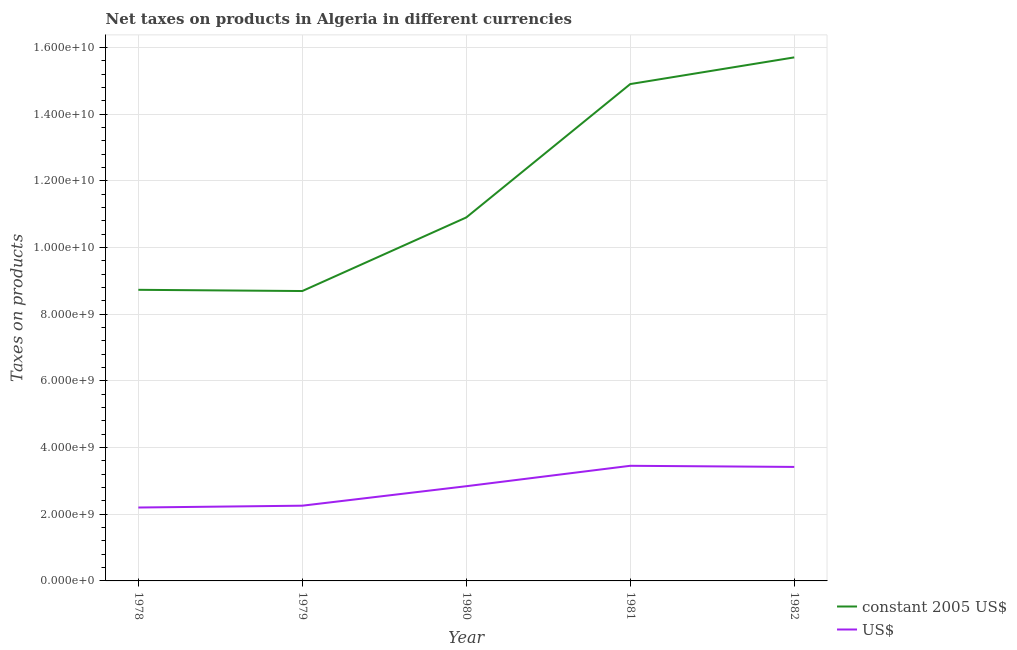How many different coloured lines are there?
Offer a terse response. 2. Does the line corresponding to net taxes in us$ intersect with the line corresponding to net taxes in constant 2005 us$?
Give a very brief answer. No. Is the number of lines equal to the number of legend labels?
Ensure brevity in your answer.  Yes. What is the net taxes in us$ in 1982?
Keep it short and to the point. 3.42e+09. Across all years, what is the maximum net taxes in constant 2005 us$?
Ensure brevity in your answer.  1.57e+1. Across all years, what is the minimum net taxes in constant 2005 us$?
Give a very brief answer. 8.69e+09. In which year was the net taxes in constant 2005 us$ minimum?
Make the answer very short. 1979. What is the total net taxes in constant 2005 us$ in the graph?
Give a very brief answer. 5.89e+1. What is the difference between the net taxes in us$ in 1979 and that in 1982?
Offer a very short reply. -1.16e+09. What is the difference between the net taxes in us$ in 1980 and the net taxes in constant 2005 us$ in 1982?
Make the answer very short. -1.29e+1. What is the average net taxes in us$ per year?
Keep it short and to the point. 2.83e+09. In the year 1982, what is the difference between the net taxes in us$ and net taxes in constant 2005 us$?
Provide a succinct answer. -1.23e+1. What is the ratio of the net taxes in us$ in 1981 to that in 1982?
Your response must be concise. 1.01. Is the net taxes in us$ in 1978 less than that in 1980?
Give a very brief answer. Yes. What is the difference between the highest and the second highest net taxes in constant 2005 us$?
Your answer should be compact. 8.00e+08. What is the difference between the highest and the lowest net taxes in us$?
Give a very brief answer. 1.25e+09. Is the sum of the net taxes in constant 2005 us$ in 1978 and 1982 greater than the maximum net taxes in us$ across all years?
Provide a succinct answer. Yes. Does the net taxes in constant 2005 us$ monotonically increase over the years?
Your response must be concise. No. Is the net taxes in us$ strictly less than the net taxes in constant 2005 us$ over the years?
Your answer should be compact. Yes. How many years are there in the graph?
Ensure brevity in your answer.  5. Does the graph contain any zero values?
Provide a short and direct response. No. Does the graph contain grids?
Your response must be concise. Yes. Where does the legend appear in the graph?
Offer a very short reply. Bottom right. What is the title of the graph?
Keep it short and to the point. Net taxes on products in Algeria in different currencies. Does "From World Bank" appear as one of the legend labels in the graph?
Provide a short and direct response. No. What is the label or title of the Y-axis?
Give a very brief answer. Taxes on products. What is the Taxes on products of constant 2005 US$ in 1978?
Ensure brevity in your answer.  8.73e+09. What is the Taxes on products of US$ in 1978?
Ensure brevity in your answer.  2.20e+09. What is the Taxes on products of constant 2005 US$ in 1979?
Offer a very short reply. 8.69e+09. What is the Taxes on products of US$ in 1979?
Keep it short and to the point. 2.26e+09. What is the Taxes on products in constant 2005 US$ in 1980?
Your answer should be very brief. 1.09e+1. What is the Taxes on products in US$ in 1980?
Give a very brief answer. 2.84e+09. What is the Taxes on products in constant 2005 US$ in 1981?
Provide a succinct answer. 1.49e+1. What is the Taxes on products of US$ in 1981?
Give a very brief answer. 3.45e+09. What is the Taxes on products of constant 2005 US$ in 1982?
Provide a short and direct response. 1.57e+1. What is the Taxes on products of US$ in 1982?
Give a very brief answer. 3.42e+09. Across all years, what is the maximum Taxes on products of constant 2005 US$?
Give a very brief answer. 1.57e+1. Across all years, what is the maximum Taxes on products in US$?
Your response must be concise. 3.45e+09. Across all years, what is the minimum Taxes on products of constant 2005 US$?
Give a very brief answer. 8.69e+09. Across all years, what is the minimum Taxes on products of US$?
Provide a succinct answer. 2.20e+09. What is the total Taxes on products of constant 2005 US$ in the graph?
Ensure brevity in your answer.  5.89e+1. What is the total Taxes on products of US$ in the graph?
Offer a very short reply. 1.42e+1. What is the difference between the Taxes on products of constant 2005 US$ in 1978 and that in 1979?
Your answer should be compact. 3.64e+07. What is the difference between the Taxes on products of US$ in 1978 and that in 1979?
Provide a short and direct response. -5.49e+07. What is the difference between the Taxes on products of constant 2005 US$ in 1978 and that in 1980?
Offer a terse response. -2.17e+09. What is the difference between the Taxes on products of US$ in 1978 and that in 1980?
Provide a succinct answer. -6.39e+08. What is the difference between the Taxes on products of constant 2005 US$ in 1978 and that in 1981?
Your answer should be compact. -6.17e+09. What is the difference between the Taxes on products in US$ in 1978 and that in 1981?
Give a very brief answer. -1.25e+09. What is the difference between the Taxes on products in constant 2005 US$ in 1978 and that in 1982?
Provide a succinct answer. -6.97e+09. What is the difference between the Taxes on products of US$ in 1978 and that in 1982?
Offer a terse response. -1.22e+09. What is the difference between the Taxes on products of constant 2005 US$ in 1979 and that in 1980?
Provide a short and direct response. -2.21e+09. What is the difference between the Taxes on products in US$ in 1979 and that in 1980?
Offer a terse response. -5.84e+08. What is the difference between the Taxes on products in constant 2005 US$ in 1979 and that in 1981?
Provide a succinct answer. -6.21e+09. What is the difference between the Taxes on products of US$ in 1979 and that in 1981?
Keep it short and to the point. -1.20e+09. What is the difference between the Taxes on products of constant 2005 US$ in 1979 and that in 1982?
Your answer should be very brief. -7.01e+09. What is the difference between the Taxes on products of US$ in 1979 and that in 1982?
Ensure brevity in your answer.  -1.16e+09. What is the difference between the Taxes on products of constant 2005 US$ in 1980 and that in 1981?
Provide a short and direct response. -4.00e+09. What is the difference between the Taxes on products in US$ in 1980 and that in 1981?
Make the answer very short. -6.12e+08. What is the difference between the Taxes on products in constant 2005 US$ in 1980 and that in 1982?
Ensure brevity in your answer.  -4.80e+09. What is the difference between the Taxes on products in US$ in 1980 and that in 1982?
Provide a short and direct response. -5.78e+08. What is the difference between the Taxes on products in constant 2005 US$ in 1981 and that in 1982?
Give a very brief answer. -8.00e+08. What is the difference between the Taxes on products of US$ in 1981 and that in 1982?
Give a very brief answer. 3.36e+07. What is the difference between the Taxes on products in constant 2005 US$ in 1978 and the Taxes on products in US$ in 1979?
Your answer should be very brief. 6.47e+09. What is the difference between the Taxes on products of constant 2005 US$ in 1978 and the Taxes on products of US$ in 1980?
Your answer should be very brief. 5.89e+09. What is the difference between the Taxes on products of constant 2005 US$ in 1978 and the Taxes on products of US$ in 1981?
Offer a terse response. 5.28e+09. What is the difference between the Taxes on products of constant 2005 US$ in 1978 and the Taxes on products of US$ in 1982?
Give a very brief answer. 5.31e+09. What is the difference between the Taxes on products in constant 2005 US$ in 1979 and the Taxes on products in US$ in 1980?
Your answer should be compact. 5.85e+09. What is the difference between the Taxes on products of constant 2005 US$ in 1979 and the Taxes on products of US$ in 1981?
Ensure brevity in your answer.  5.24e+09. What is the difference between the Taxes on products in constant 2005 US$ in 1979 and the Taxes on products in US$ in 1982?
Ensure brevity in your answer.  5.27e+09. What is the difference between the Taxes on products in constant 2005 US$ in 1980 and the Taxes on products in US$ in 1981?
Your answer should be compact. 7.45e+09. What is the difference between the Taxes on products in constant 2005 US$ in 1980 and the Taxes on products in US$ in 1982?
Make the answer very short. 7.48e+09. What is the difference between the Taxes on products in constant 2005 US$ in 1981 and the Taxes on products in US$ in 1982?
Give a very brief answer. 1.15e+1. What is the average Taxes on products in constant 2005 US$ per year?
Provide a succinct answer. 1.18e+1. What is the average Taxes on products in US$ per year?
Your answer should be very brief. 2.83e+09. In the year 1978, what is the difference between the Taxes on products in constant 2005 US$ and Taxes on products in US$?
Give a very brief answer. 6.53e+09. In the year 1979, what is the difference between the Taxes on products of constant 2005 US$ and Taxes on products of US$?
Provide a short and direct response. 6.44e+09. In the year 1980, what is the difference between the Taxes on products in constant 2005 US$ and Taxes on products in US$?
Ensure brevity in your answer.  8.06e+09. In the year 1981, what is the difference between the Taxes on products in constant 2005 US$ and Taxes on products in US$?
Ensure brevity in your answer.  1.14e+1. In the year 1982, what is the difference between the Taxes on products of constant 2005 US$ and Taxes on products of US$?
Your response must be concise. 1.23e+1. What is the ratio of the Taxes on products in constant 2005 US$ in 1978 to that in 1979?
Provide a succinct answer. 1. What is the ratio of the Taxes on products of US$ in 1978 to that in 1979?
Offer a terse response. 0.98. What is the ratio of the Taxes on products of constant 2005 US$ in 1978 to that in 1980?
Offer a terse response. 0.8. What is the ratio of the Taxes on products of US$ in 1978 to that in 1980?
Your response must be concise. 0.78. What is the ratio of the Taxes on products of constant 2005 US$ in 1978 to that in 1981?
Your response must be concise. 0.59. What is the ratio of the Taxes on products of US$ in 1978 to that in 1981?
Offer a very short reply. 0.64. What is the ratio of the Taxes on products of constant 2005 US$ in 1978 to that in 1982?
Provide a succinct answer. 0.56. What is the ratio of the Taxes on products of US$ in 1978 to that in 1982?
Your answer should be very brief. 0.64. What is the ratio of the Taxes on products in constant 2005 US$ in 1979 to that in 1980?
Offer a terse response. 0.8. What is the ratio of the Taxes on products of US$ in 1979 to that in 1980?
Give a very brief answer. 0.79. What is the ratio of the Taxes on products of constant 2005 US$ in 1979 to that in 1981?
Your answer should be very brief. 0.58. What is the ratio of the Taxes on products of US$ in 1979 to that in 1981?
Make the answer very short. 0.65. What is the ratio of the Taxes on products of constant 2005 US$ in 1979 to that in 1982?
Keep it short and to the point. 0.55. What is the ratio of the Taxes on products of US$ in 1979 to that in 1982?
Your answer should be compact. 0.66. What is the ratio of the Taxes on products of constant 2005 US$ in 1980 to that in 1981?
Your answer should be very brief. 0.73. What is the ratio of the Taxes on products in US$ in 1980 to that in 1981?
Offer a terse response. 0.82. What is the ratio of the Taxes on products in constant 2005 US$ in 1980 to that in 1982?
Make the answer very short. 0.69. What is the ratio of the Taxes on products of US$ in 1980 to that in 1982?
Give a very brief answer. 0.83. What is the ratio of the Taxes on products in constant 2005 US$ in 1981 to that in 1982?
Give a very brief answer. 0.95. What is the ratio of the Taxes on products in US$ in 1981 to that in 1982?
Your response must be concise. 1.01. What is the difference between the highest and the second highest Taxes on products of constant 2005 US$?
Make the answer very short. 8.00e+08. What is the difference between the highest and the second highest Taxes on products of US$?
Make the answer very short. 3.36e+07. What is the difference between the highest and the lowest Taxes on products of constant 2005 US$?
Ensure brevity in your answer.  7.01e+09. What is the difference between the highest and the lowest Taxes on products of US$?
Make the answer very short. 1.25e+09. 